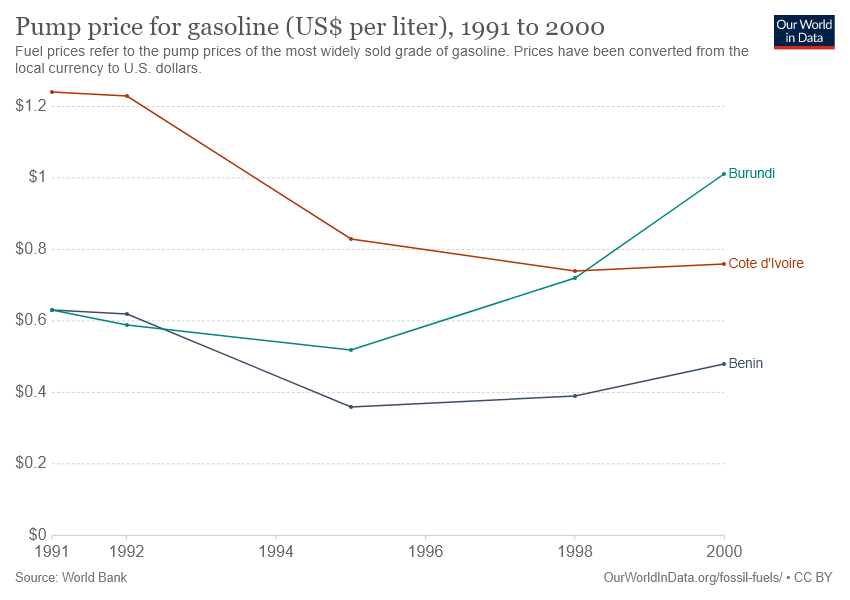Draw attention to some important aspects in this diagram. Burundi and Cote d'Ivoire's lines crossed each other at least once. The year with the highest recorded pump price for gasoline in Burundi was 2000. 